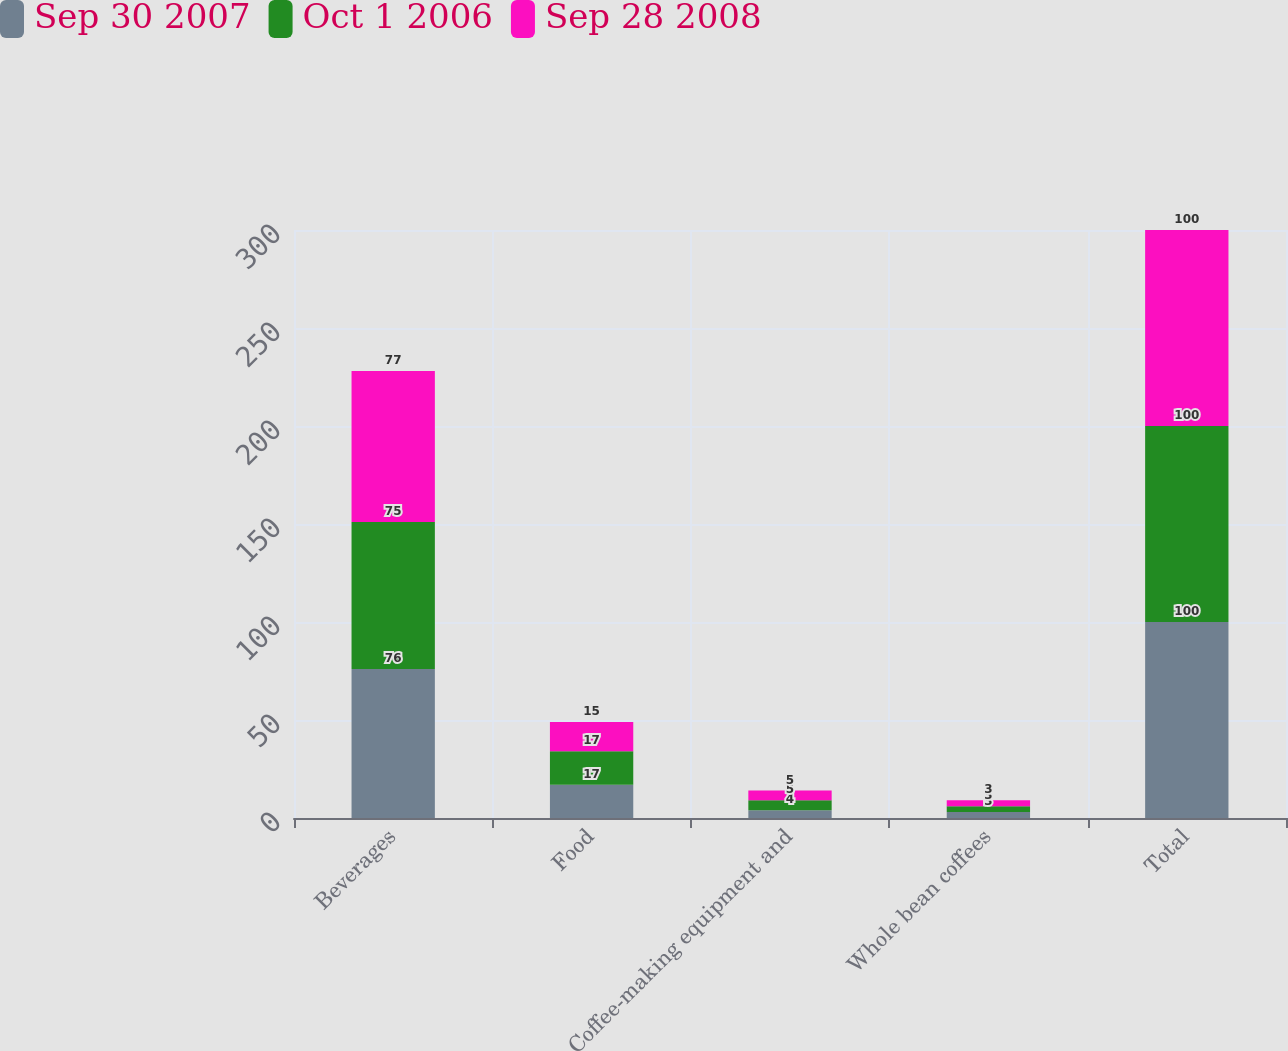<chart> <loc_0><loc_0><loc_500><loc_500><stacked_bar_chart><ecel><fcel>Beverages<fcel>Food<fcel>Coffee-making equipment and<fcel>Whole bean coffees<fcel>Total<nl><fcel>Sep 30 2007<fcel>76<fcel>17<fcel>4<fcel>3<fcel>100<nl><fcel>Oct 1 2006<fcel>75<fcel>17<fcel>5<fcel>3<fcel>100<nl><fcel>Sep 28 2008<fcel>77<fcel>15<fcel>5<fcel>3<fcel>100<nl></chart> 